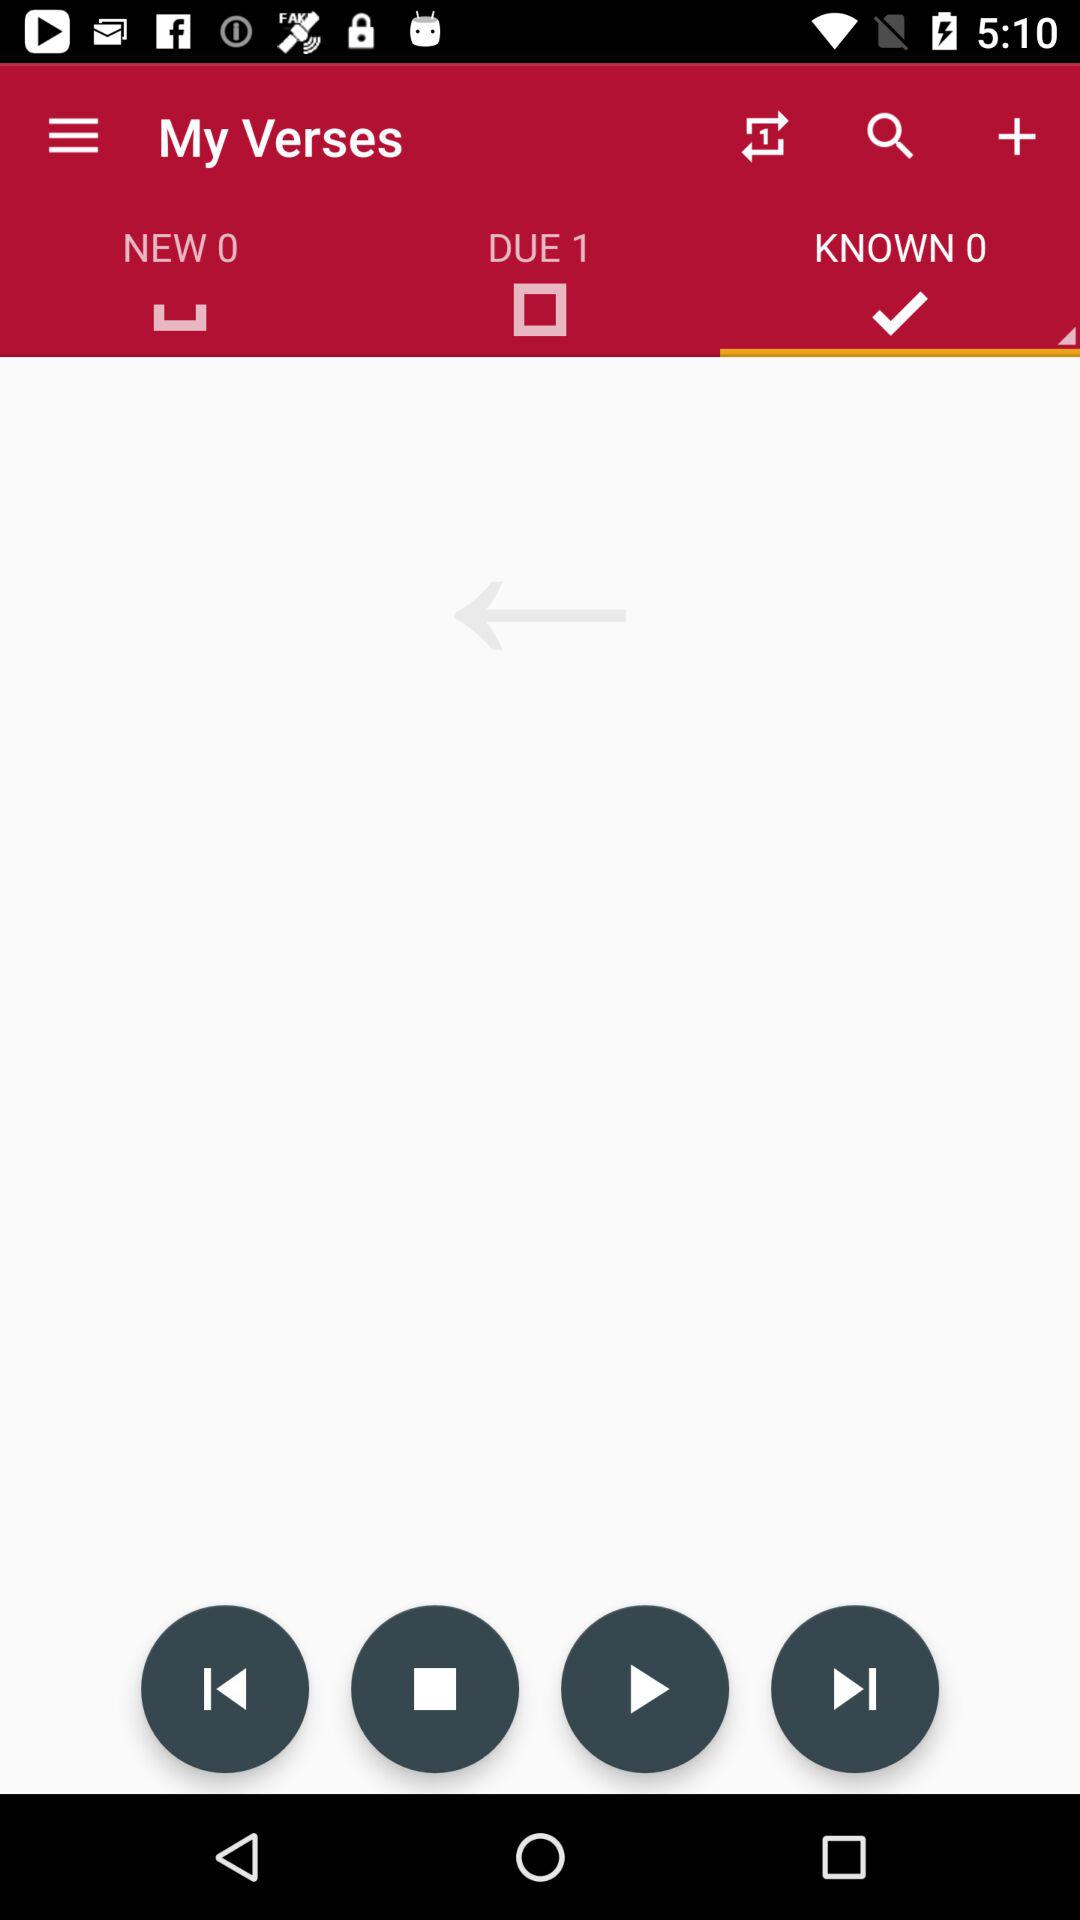How many people are expected here?
When the provided information is insufficient, respond with <no answer>. <no answer> 